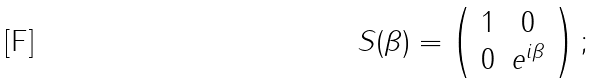Convert formula to latex. <formula><loc_0><loc_0><loc_500><loc_500>S ( \beta ) = \left ( \begin{array} { c c } 1 & 0 \\ 0 & e ^ { i \beta } \end{array} \right ) ;</formula> 